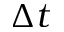<formula> <loc_0><loc_0><loc_500><loc_500>\Delta t</formula> 